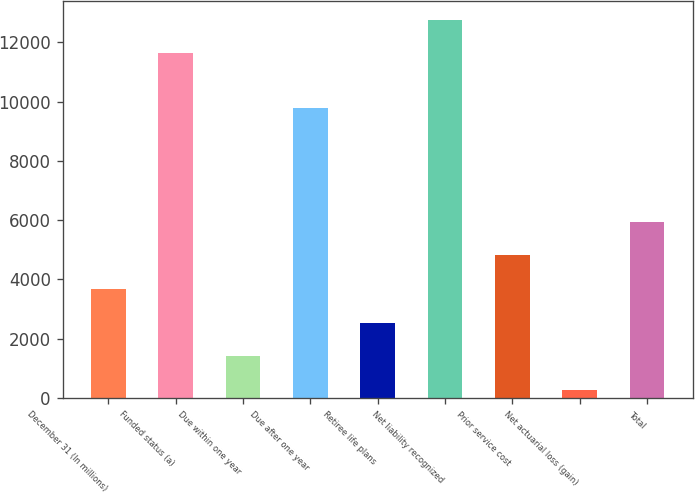Convert chart. <chart><loc_0><loc_0><loc_500><loc_500><bar_chart><fcel>December 31 (In millions)<fcel>Funded status (a)<fcel>Due within one year<fcel>Due after one year<fcel>Retiree life plans<fcel>Net liability recognized<fcel>Prior service cost<fcel>Net actuarial loss (gain)<fcel>Total<nl><fcel>3681.5<fcel>11637<fcel>1408.5<fcel>9790<fcel>2545<fcel>12773.5<fcel>4818<fcel>272<fcel>5954.5<nl></chart> 